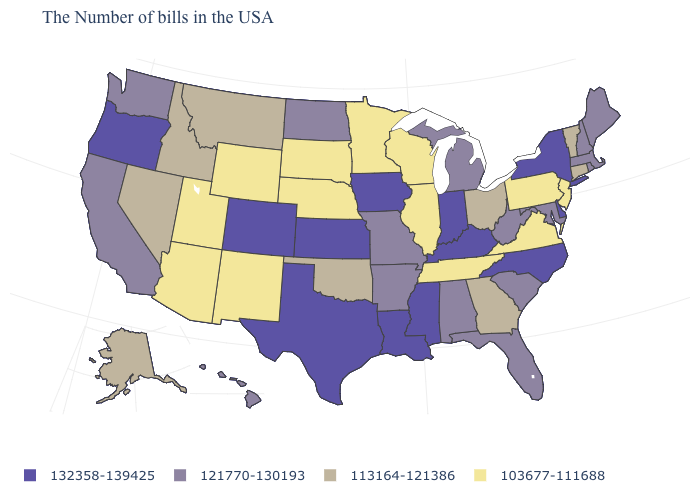Name the states that have a value in the range 132358-139425?
Quick response, please. New York, Delaware, North Carolina, Kentucky, Indiana, Mississippi, Louisiana, Iowa, Kansas, Texas, Colorado, Oregon. What is the value of Indiana?
Write a very short answer. 132358-139425. Name the states that have a value in the range 103677-111688?
Give a very brief answer. New Jersey, Pennsylvania, Virginia, Tennessee, Wisconsin, Illinois, Minnesota, Nebraska, South Dakota, Wyoming, New Mexico, Utah, Arizona. What is the value of Wyoming?
Be succinct. 103677-111688. What is the highest value in states that border Massachusetts?
Keep it brief. 132358-139425. What is the value of Rhode Island?
Keep it brief. 121770-130193. What is the highest value in states that border Vermont?
Be succinct. 132358-139425. Among the states that border Iowa , which have the lowest value?
Write a very short answer. Wisconsin, Illinois, Minnesota, Nebraska, South Dakota. Does the map have missing data?
Answer briefly. No. Does Virginia have a higher value than California?
Answer briefly. No. Is the legend a continuous bar?
Short answer required. No. What is the value of West Virginia?
Short answer required. 121770-130193. What is the highest value in states that border Kansas?
Give a very brief answer. 132358-139425. Does Kentucky have the highest value in the South?
Be succinct. Yes. Among the states that border Alabama , which have the lowest value?
Short answer required. Tennessee. 